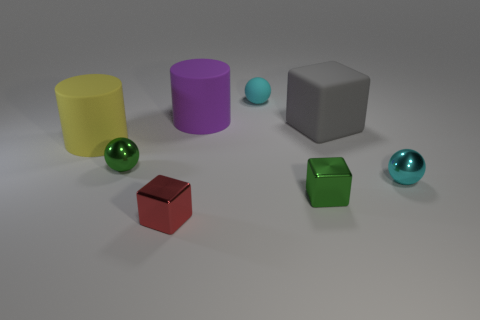What is the size of the shiny ball that is the same color as the small matte object?
Offer a terse response. Small. What number of purple things are matte things or tiny cubes?
Your answer should be very brief. 1. How many other things are there of the same size as the green block?
Your answer should be compact. 4. How many tiny things are either cyan shiny objects or purple rubber cylinders?
Offer a terse response. 1. There is a green metallic block; is its size the same as the shiny ball to the right of the red shiny object?
Provide a short and direct response. Yes. How many other objects are the same shape as the large purple thing?
Give a very brief answer. 1. There is a small red thing that is the same material as the green block; what is its shape?
Your answer should be very brief. Cube. Are any big yellow shiny cylinders visible?
Make the answer very short. No. Are there fewer cyan rubber objects that are in front of the tiny red thing than tiny green things on the right side of the purple object?
Offer a very short reply. Yes. What is the shape of the large yellow thing behind the tiny red metal cube?
Ensure brevity in your answer.  Cylinder. 